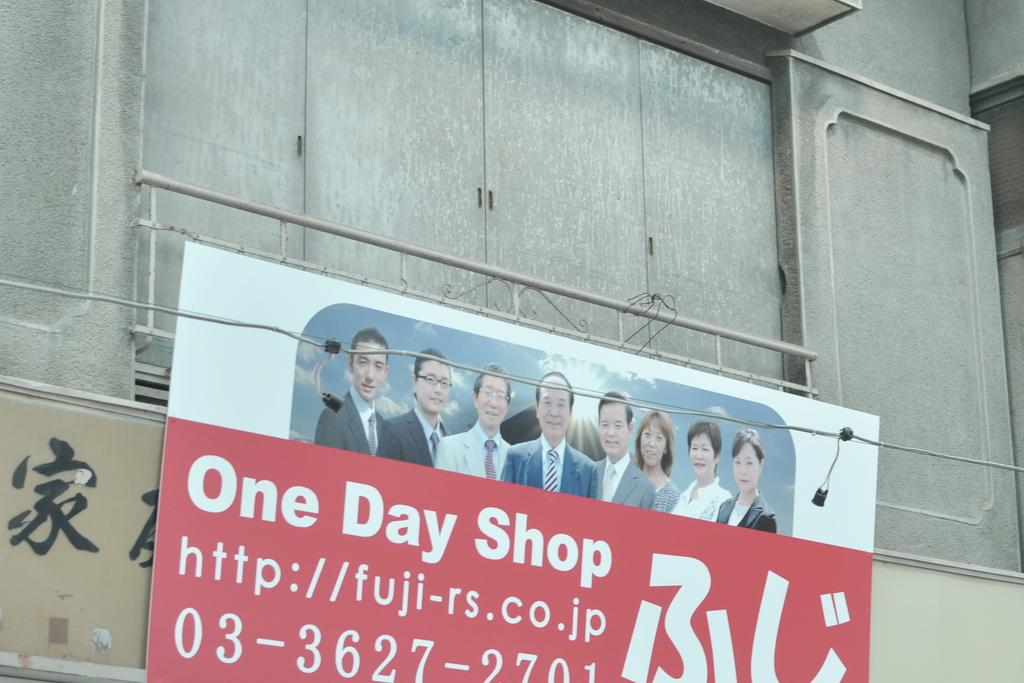<image>
Share a concise interpretation of the image provided. A sign for something called the One Day Shop. 